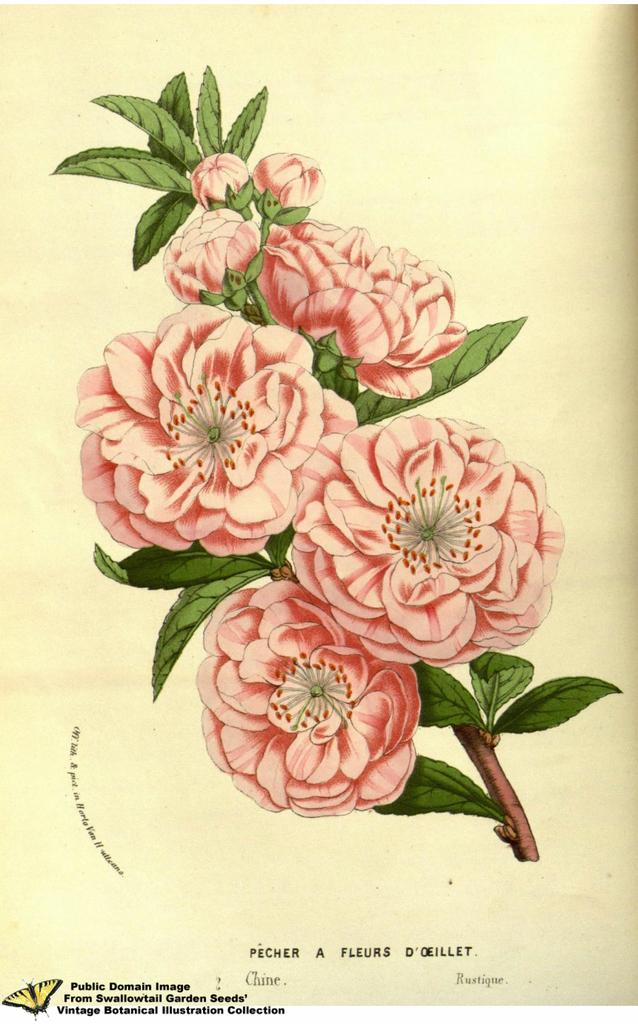What type of content is present in the image? There are words and a picture of a plant in the image. Can you describe the plant in the image? The plant has flowers, buds, and leaves. What is the image printed on? The image is on a paper. Is there any additional marking on the paper? Yes, there is a watermark in the bottom left corner of the image. What type of cake is being sold in the shop depicted in the image? There is no shop or cake present in the image; it features words and a picture of a plant on a paper with a watermark. What religious symbol can be seen in the image? There is no religious symbol present in the image; it features words and a picture of a plant on a paper with a watermark. 